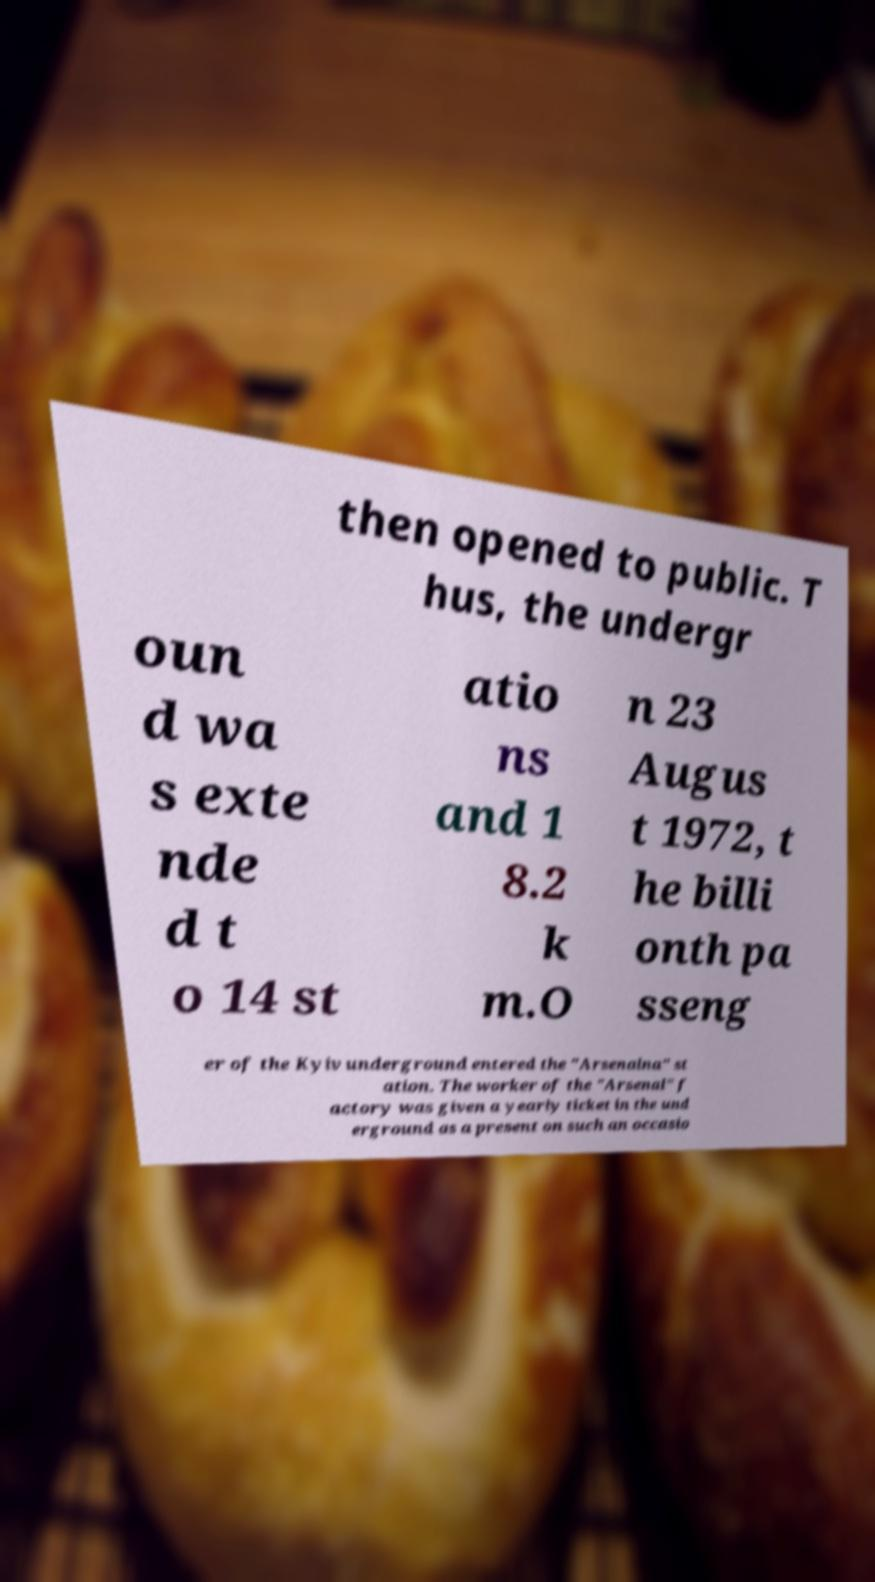Please read and relay the text visible in this image. What does it say? then opened to public. T hus, the undergr oun d wa s exte nde d t o 14 st atio ns and 1 8.2 k m.O n 23 Augus t 1972, t he billi onth pa sseng er of the Kyiv underground entered the "Arsenalna" st ation. The worker of the "Arsenal" f actory was given a yearly ticket in the und erground as a present on such an occasio 